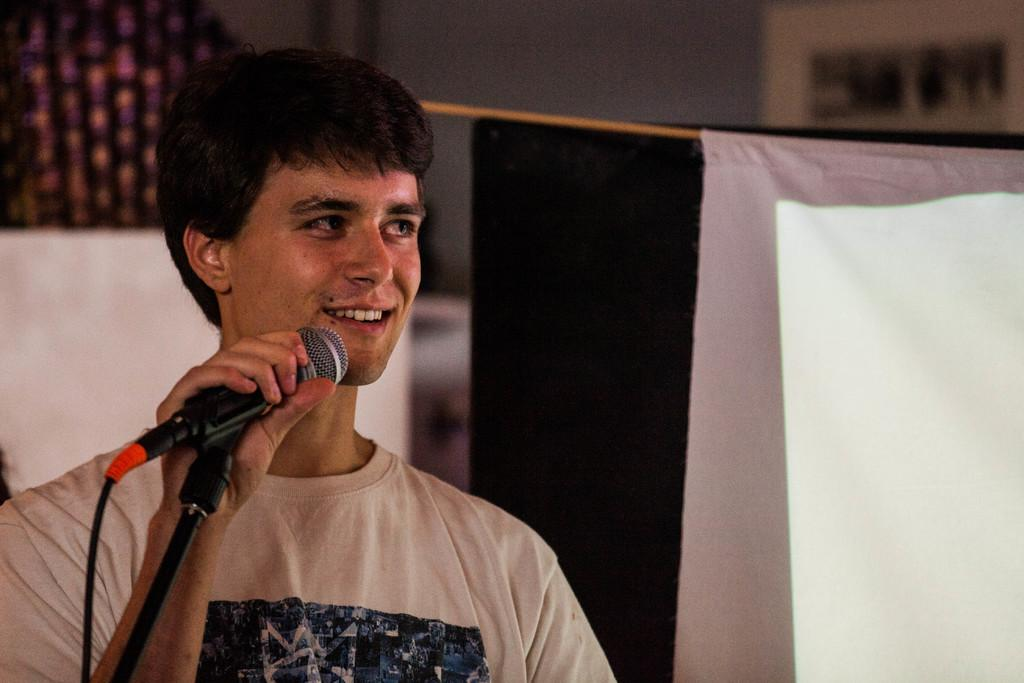What is the man in the image doing? The man is standing in the image and holding a microphone. What can be inferred about the man's activity based on the microphone? The man might be giving a speech or performing, as he is holding a microphone. What color is the microphone in the image? The microphone is black in color. What else can be seen in the image besides the man and the microphone? There is a curtain in the image. What is the color of the curtain? The curtain is white in color. How many cacti are present on the stage in the image? There are no cacti visible in the image; it features a man holding a microphone and a white curtain. What type of company is the man representing in the image? There is no indication of a company or any affiliation in the image; it simply shows a man holding a microphone and a white curtain. 